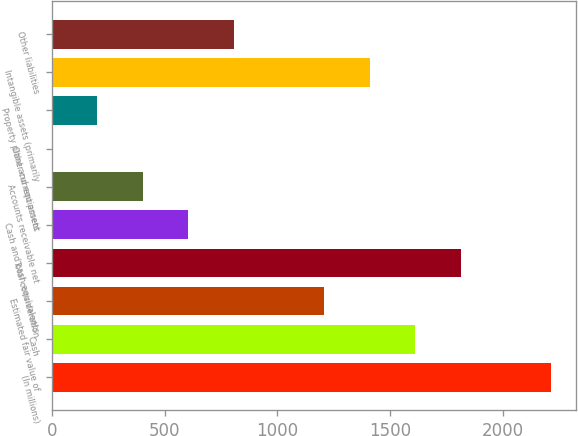Convert chart. <chart><loc_0><loc_0><loc_500><loc_500><bar_chart><fcel>(In millions)<fcel>Cash<fcel>Estimated fair value of<fcel>Total consideration<fcel>Cash and cash equivalents<fcel>Accounts receivable net<fcel>Other current assets<fcel>Property plant and equipment<fcel>Intangible assets (primarily<fcel>Other liabilities<nl><fcel>2215.3<fcel>1611.4<fcel>1208.8<fcel>1812.7<fcel>604.9<fcel>403.6<fcel>1<fcel>202.3<fcel>1410.1<fcel>806.2<nl></chart> 